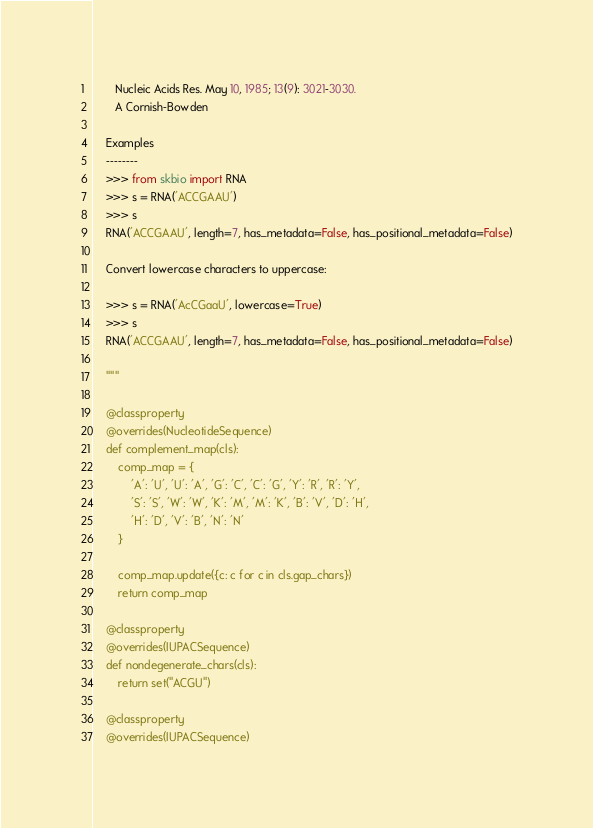<code> <loc_0><loc_0><loc_500><loc_500><_Python_>       Nucleic Acids Res. May 10, 1985; 13(9): 3021-3030.
       A Cornish-Bowden

    Examples
    --------
    >>> from skbio import RNA
    >>> s = RNA('ACCGAAU')
    >>> s
    RNA('ACCGAAU', length=7, has_metadata=False, has_positional_metadata=False)

    Convert lowercase characters to uppercase:

    >>> s = RNA('AcCGaaU', lowercase=True)
    >>> s
    RNA('ACCGAAU', length=7, has_metadata=False, has_positional_metadata=False)

    """

    @classproperty
    @overrides(NucleotideSequence)
    def complement_map(cls):
        comp_map = {
            'A': 'U', 'U': 'A', 'G': 'C', 'C': 'G', 'Y': 'R', 'R': 'Y',
            'S': 'S', 'W': 'W', 'K': 'M', 'M': 'K', 'B': 'V', 'D': 'H',
            'H': 'D', 'V': 'B', 'N': 'N'
        }

        comp_map.update({c: c for c in cls.gap_chars})
        return comp_map

    @classproperty
    @overrides(IUPACSequence)
    def nondegenerate_chars(cls):
        return set("ACGU")

    @classproperty
    @overrides(IUPACSequence)</code> 